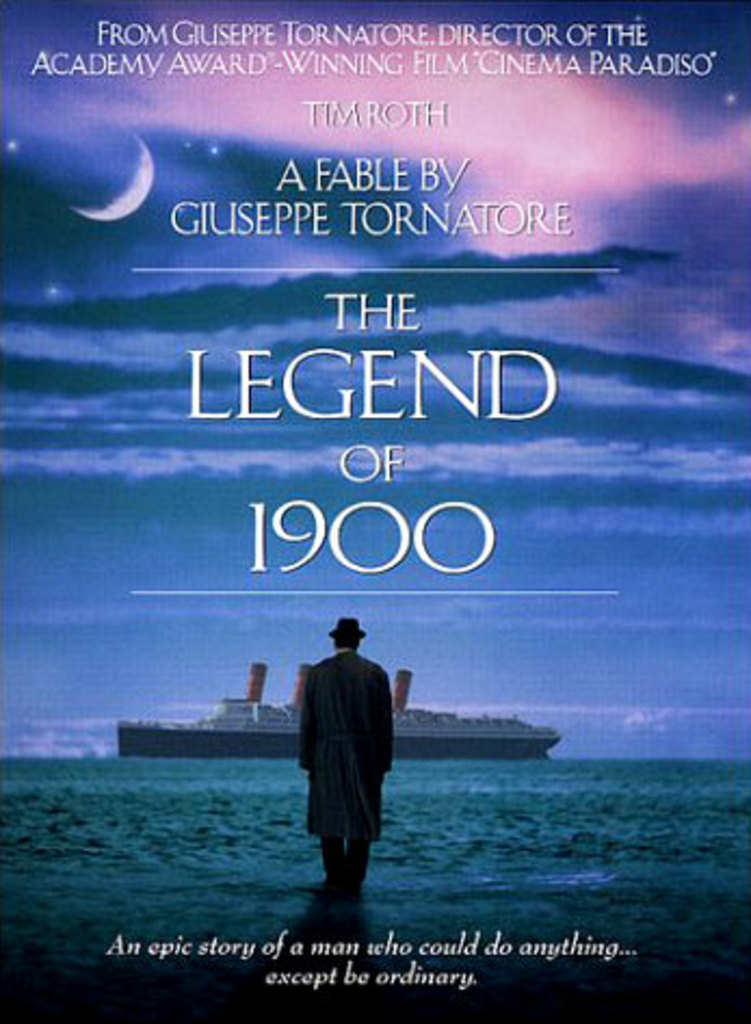Why do you think the tagline focuses on the protagonist's inability to be ordinary? By highlighting the protagonist's inability to be ordinary, the tagline cleverly plays on the allure of the unique and exceptional. It suggests that the movie will explore themes of individuality and the extraordinary, possibly challenging the viewer's perception of what it means to lead a significant life. 